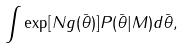Convert formula to latex. <formula><loc_0><loc_0><loc_500><loc_500>\int \exp [ N g ( \bar { \theta } ) ] P ( \bar { \theta } | M ) d \bar { \theta } ,</formula> 